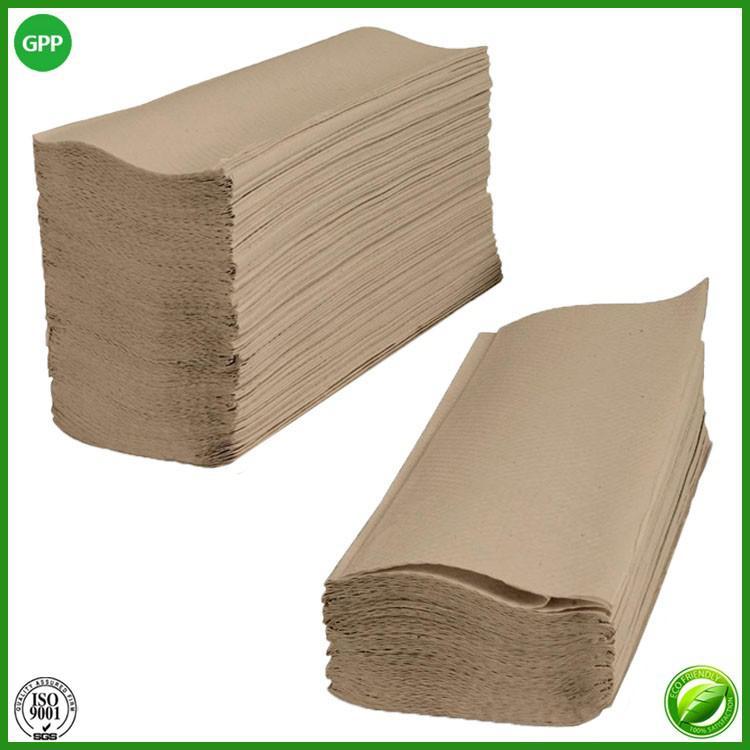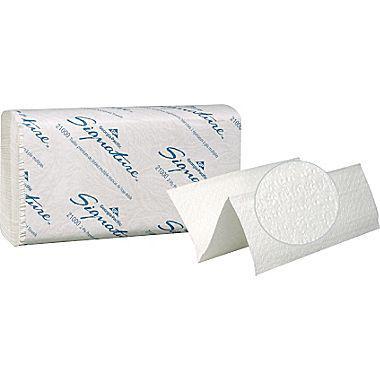The first image is the image on the left, the second image is the image on the right. Considering the images on both sides, is "At least one image features one accordion-folded paper towel in front of a stack of folded white paper towels wrapped in printed paper." valid? Answer yes or no. Yes. The first image is the image on the left, the second image is the image on the right. Examine the images to the left and right. Is the description "a single stack of paper towels is wrapped in paper packaging with a single towel next to it" accurate? Answer yes or no. Yes. 